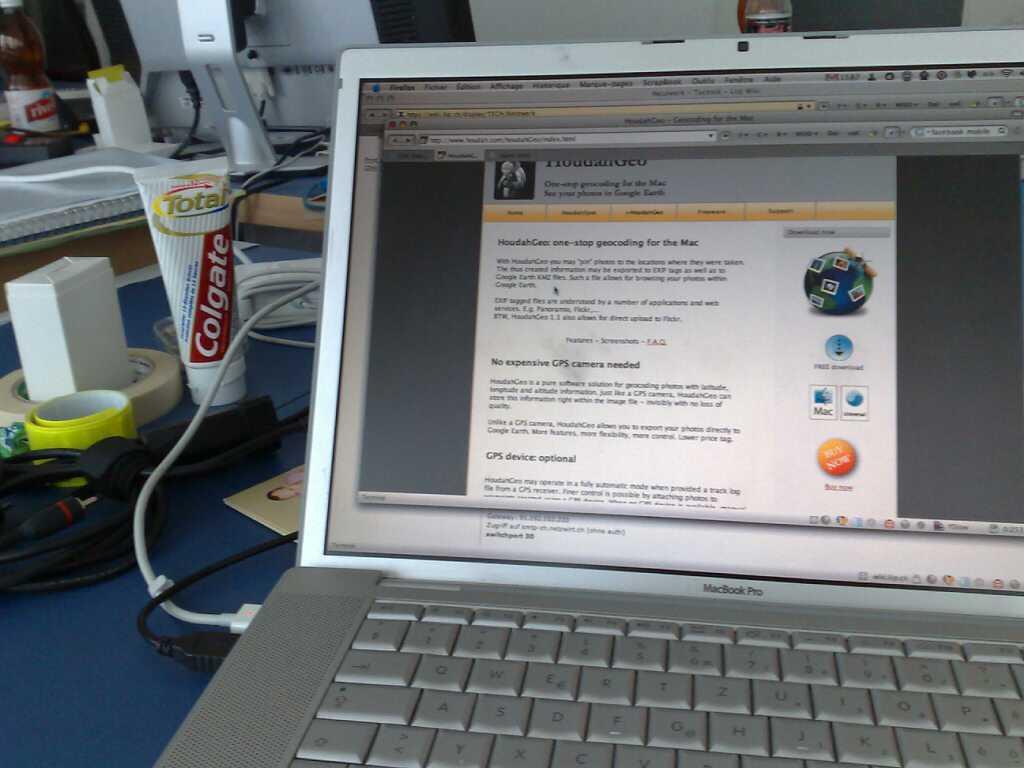What brand of toothpaste is located on the left?
Give a very brief answer. Colgate. What kind of laptop is this?
Your answer should be very brief. Macbook pro. 